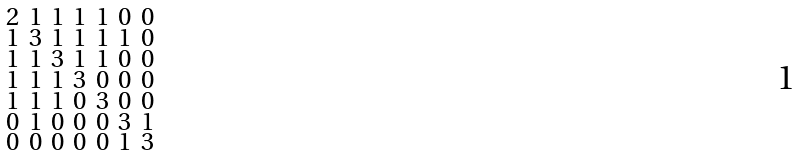<formula> <loc_0><loc_0><loc_500><loc_500>\begin{smallmatrix} 2 & 1 & 1 & 1 & 1 & 0 & 0 \\ 1 & 3 & 1 & 1 & 1 & 1 & 0 \\ 1 & 1 & 3 & 1 & 1 & 0 & 0 \\ 1 & 1 & 1 & 3 & 0 & 0 & 0 \\ 1 & 1 & 1 & 0 & 3 & 0 & 0 \\ 0 & 1 & 0 & 0 & 0 & 3 & 1 \\ 0 & 0 & 0 & 0 & 0 & 1 & 3 \end{smallmatrix}</formula> 